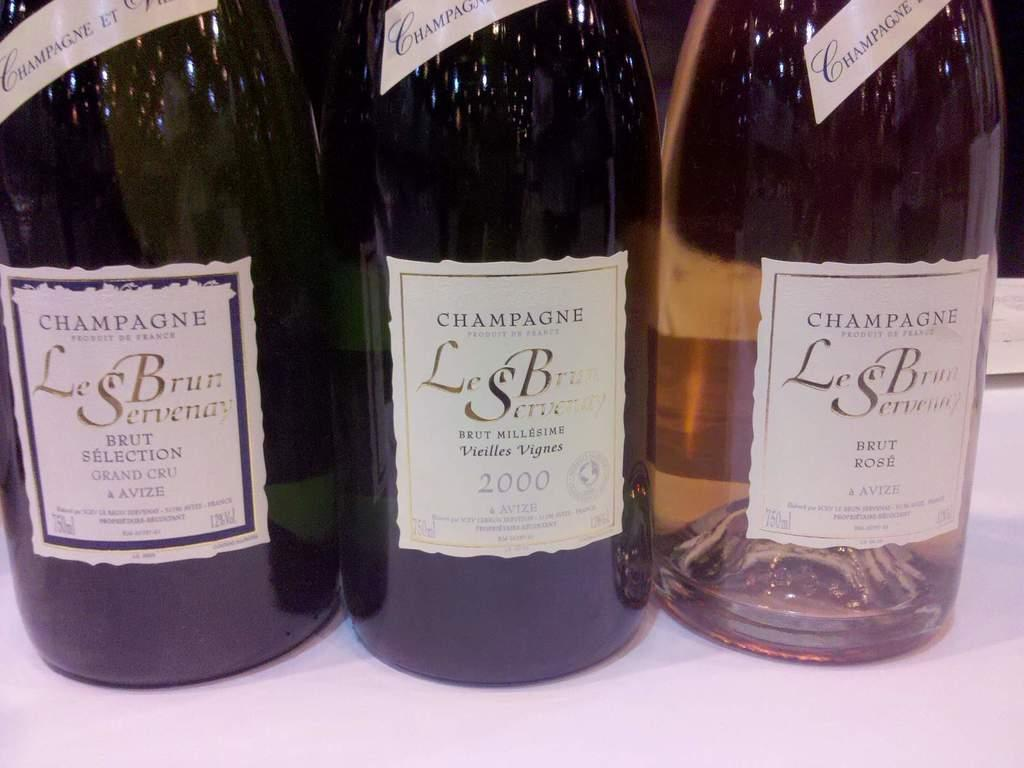<image>
Describe the image concisely. The middle champagne of three was bottled in 2000. 